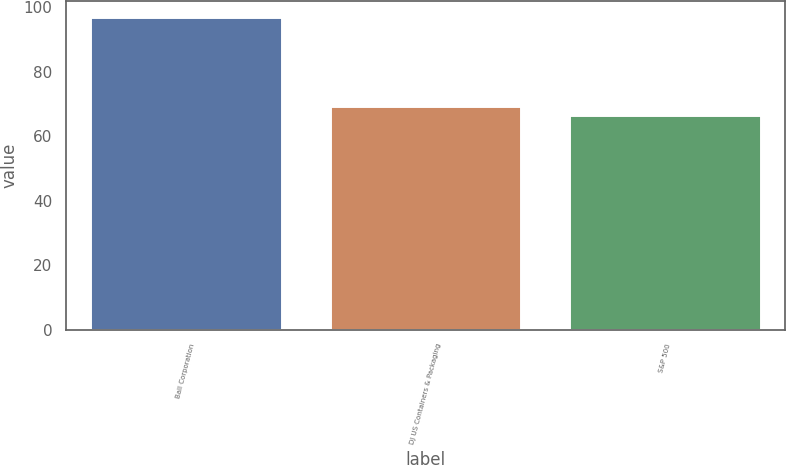<chart> <loc_0><loc_0><loc_500><loc_500><bar_chart><fcel>Ball Corporation<fcel>DJ US Containers & Packaging<fcel>S&P 500<nl><fcel>97.04<fcel>69.52<fcel>66.46<nl></chart> 